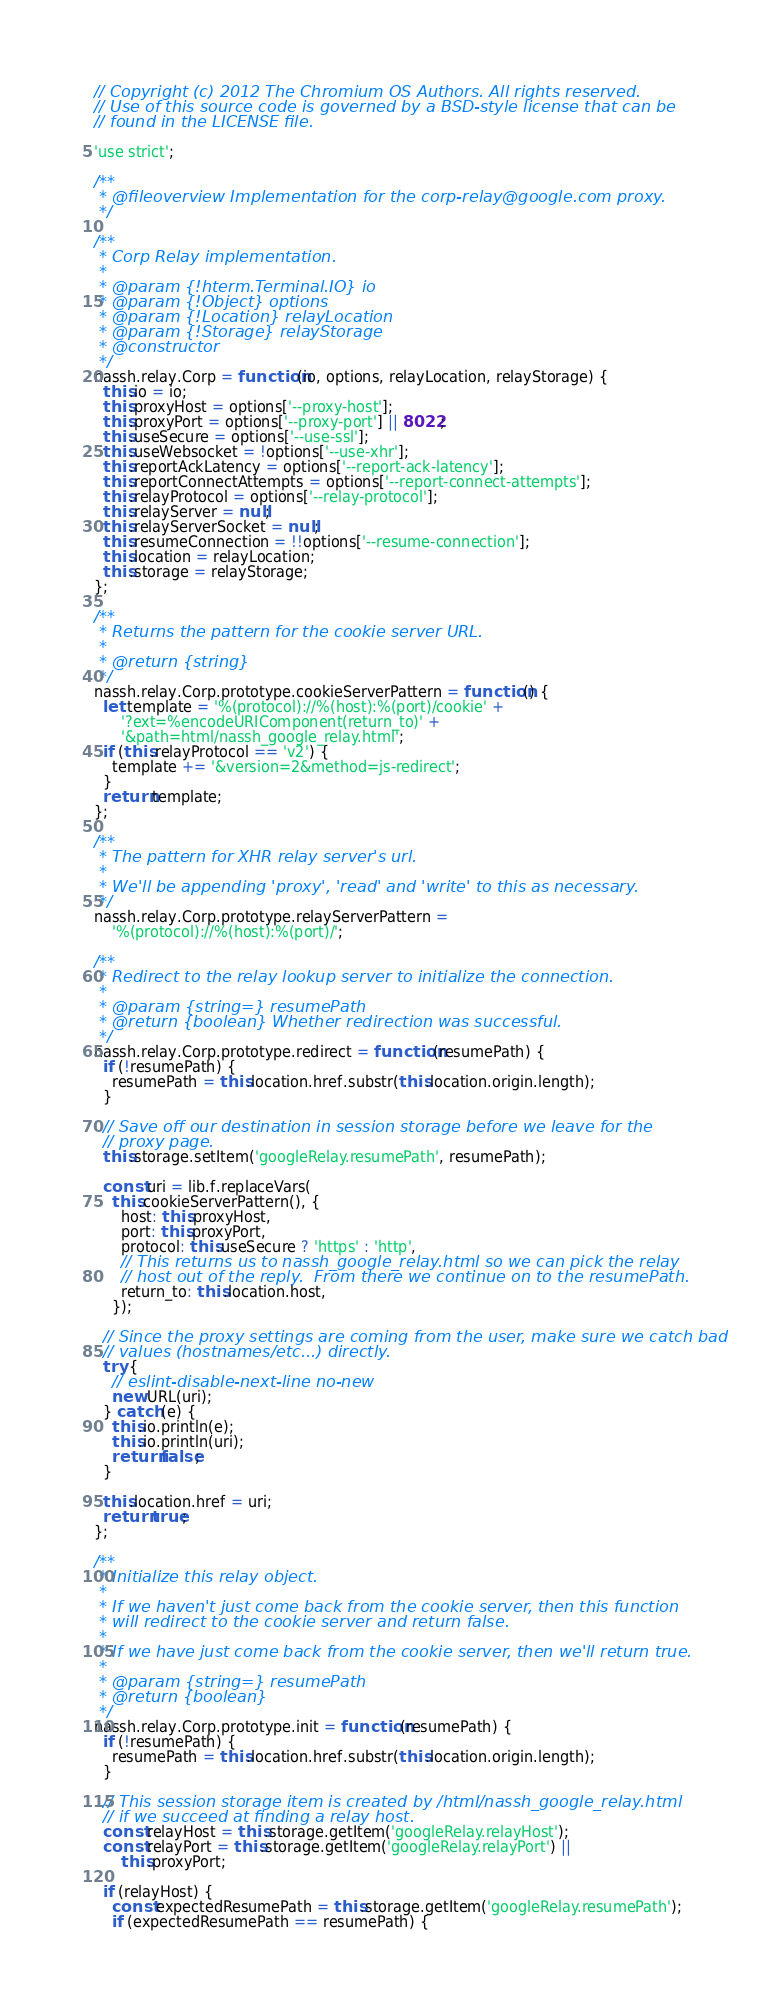Convert code to text. <code><loc_0><loc_0><loc_500><loc_500><_JavaScript_>// Copyright (c) 2012 The Chromium OS Authors. All rights reserved.
// Use of this source code is governed by a BSD-style license that can be
// found in the LICENSE file.

'use strict';

/**
 * @fileoverview Implementation for the corp-relay@google.com proxy.
 */

/**
 * Corp Relay implementation.
 *
 * @param {!hterm.Terminal.IO} io
 * @param {!Object} options
 * @param {!Location} relayLocation
 * @param {!Storage} relayStorage
 * @constructor
 */
nassh.relay.Corp = function(io, options, relayLocation, relayStorage) {
  this.io = io;
  this.proxyHost = options['--proxy-host'];
  this.proxyPort = options['--proxy-port'] || 8022;
  this.useSecure = options['--use-ssl'];
  this.useWebsocket = !options['--use-xhr'];
  this.reportAckLatency = options['--report-ack-latency'];
  this.reportConnectAttempts = options['--report-connect-attempts'];
  this.relayProtocol = options['--relay-protocol'];
  this.relayServer = null;
  this.relayServerSocket = null;
  this.resumeConnection = !!options['--resume-connection'];
  this.location = relayLocation;
  this.storage = relayStorage;
};

/**
 * Returns the pattern for the cookie server URL.
 *
 * @return {string}
 */
nassh.relay.Corp.prototype.cookieServerPattern = function() {
  let template = '%(protocol)://%(host):%(port)/cookie' +
      '?ext=%encodeURIComponent(return_to)' +
      '&path=html/nassh_google_relay.html';
  if (this.relayProtocol == 'v2') {
    template += '&version=2&method=js-redirect';
  }
  return template;
};

/**
 * The pattern for XHR relay server's url.
 *
 * We'll be appending 'proxy', 'read' and 'write' to this as necessary.
 */
nassh.relay.Corp.prototype.relayServerPattern =
    '%(protocol)://%(host):%(port)/';

/**
 * Redirect to the relay lookup server to initialize the connection.
 *
 * @param {string=} resumePath
 * @return {boolean} Whether redirection was successful.
 */
nassh.relay.Corp.prototype.redirect = function(resumePath) {
  if (!resumePath) {
    resumePath = this.location.href.substr(this.location.origin.length);
  }

  // Save off our destination in session storage before we leave for the
  // proxy page.
  this.storage.setItem('googleRelay.resumePath', resumePath);

  const uri = lib.f.replaceVars(
    this.cookieServerPattern(), {
      host: this.proxyHost,
      port: this.proxyPort,
      protocol: this.useSecure ? 'https' : 'http',
      // This returns us to nassh_google_relay.html so we can pick the relay
      // host out of the reply.  From there we continue on to the resumePath.
      return_to: this.location.host,
    });

  // Since the proxy settings are coming from the user, make sure we catch bad
  // values (hostnames/etc...) directly.
  try {
    // eslint-disable-next-line no-new
    new URL(uri);
  } catch (e) {
    this.io.println(e);
    this.io.println(uri);
    return false;
  }

  this.location.href = uri;
  return true;
};

/**
 * Initialize this relay object.
 *
 * If we haven't just come back from the cookie server, then this function
 * will redirect to the cookie server and return false.
 *
 * If we have just come back from the cookie server, then we'll return true.
 *
 * @param {string=} resumePath
 * @return {boolean}
 */
nassh.relay.Corp.prototype.init = function(resumePath) {
  if (!resumePath) {
    resumePath = this.location.href.substr(this.location.origin.length);
  }

  // This session storage item is created by /html/nassh_google_relay.html
  // if we succeed at finding a relay host.
  const relayHost = this.storage.getItem('googleRelay.relayHost');
  const relayPort = this.storage.getItem('googleRelay.relayPort') ||
      this.proxyPort;

  if (relayHost) {
    const expectedResumePath = this.storage.getItem('googleRelay.resumePath');
    if (expectedResumePath == resumePath) {</code> 